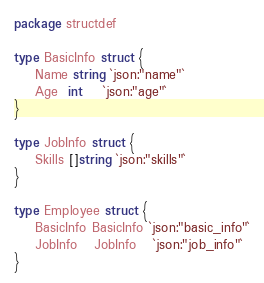Convert code to text. <code><loc_0><loc_0><loc_500><loc_500><_Go_>package structdef

type BasicInfo struct {
	Name string `json:"name"`
	Age  int    `json:"age"`
}

type JobInfo struct {
	Skills []string `json:"skills"`
}

type Employee struct {
	BasicInfo BasicInfo `json:"basic_info"`
	JobInfo   JobInfo   `json:"job_info"`
}
</code> 